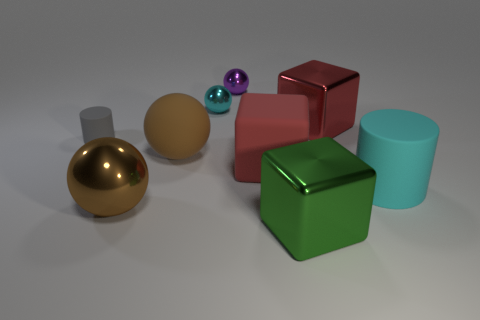What materials could these objects be representing, given their different appearances? The objects seem to be computer-generated and are likely intended to represent various materials such as polished gold, matte ceramics, and perhaps glossy or metallic-painted plastics. 